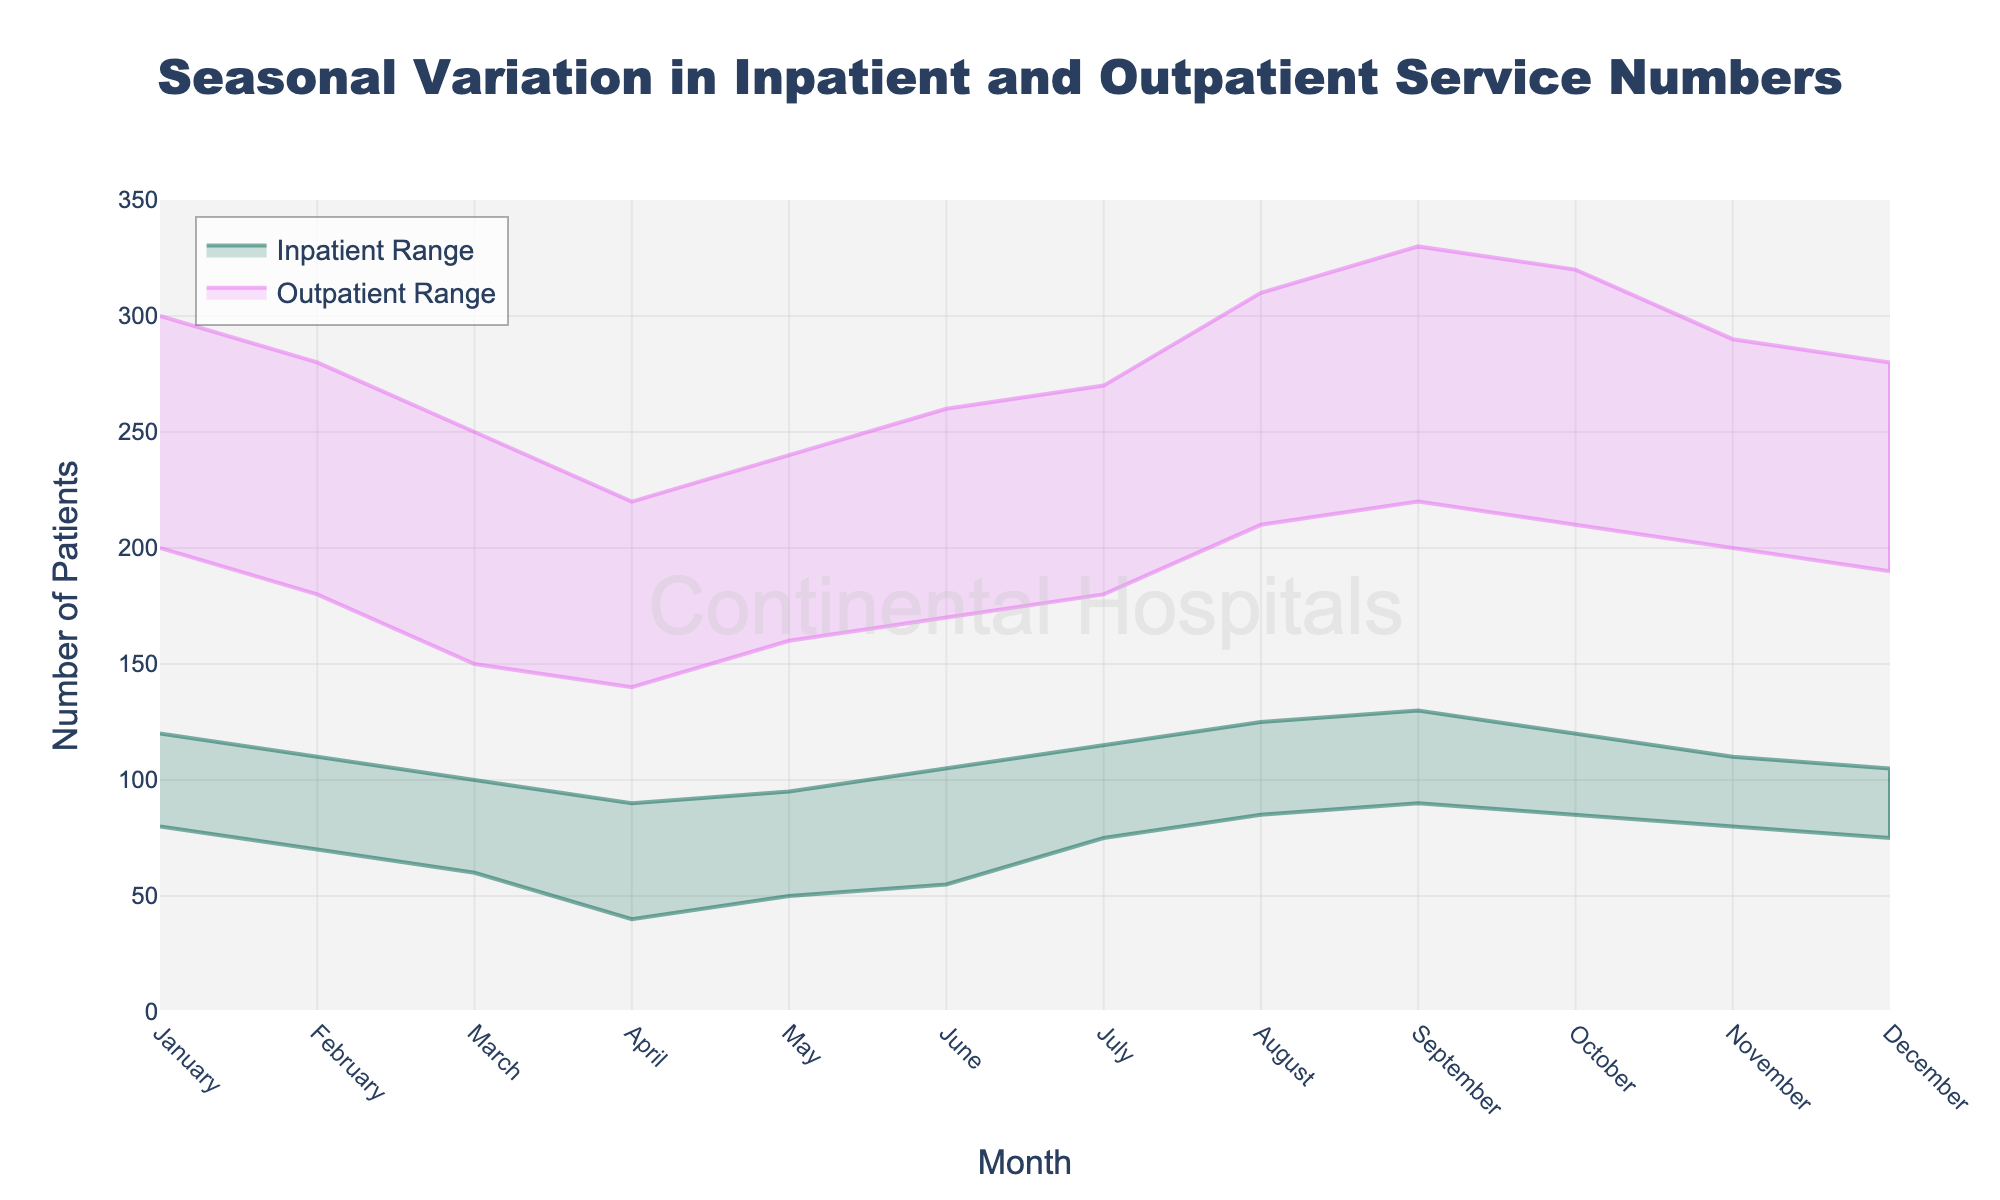what is the title of the plot? The title is located at the top center of the figure. It reads, "Seasonal Variation in Inpatient and Outpatient Service Numbers," indicating the chart’s focus.
Answer: Seasonal Variation in Inpatient and Outpatient Service Numbers What are the x-axis and y-axis titles? The x-axis title is at the bottom of the figure and reads "Month," while the y-axis title is on the left side and reads "Number of Patients."
Answer: x-axis: Month; y-axis: Number of Patients In which month is the maximum number of Inpatients the highest? The Inpatient range is represented by a green shaded area. The highest peak of the green area is in September, reaching 130 patients.
Answer: September Which month has the smallest range for Outpatient numbers? The Outpatient range is shown by the purple shaded area. April has the smallest range (140 to 220), making it just 80 patients.
Answer: April How does the range of Inpatient numbers compare between January and February? Inpatient numbers range from 80 to 120 in January and from 70 to 110 in February. The range for January (40) is larger than that for February (40 vs. 40).
range being the same.
Answer: Both 40 By how much do the minimum Inpatient numbers increase from March to April? The minimum Inpatient numbers increase from 60 in March to 40 in April. The difference is calculated as 60 - 40 = 10 patients.
Answer: 10 patients What is the difference between the maximum Outpatient numbers in June and July? The maximum Outpatient numbers are shown on the top edge of the purple area. June has a maximum of 260, and July has a maximum of 270. The difference is calculated as 270 - 260 = 10 patients.
Answer: 10 patients In which months do both the minimum and maximum Outpatient numbers reach their peak? The purple shaded area’s top and bottom edges (max and min) are highest in September, with the maximum being 330 and the minimum being 220.
Answer: September Which month shows a significant decline in both Inpatient and Outpatient numbers compared to its preceding month? By comparing the range edges, both Inpatient and Outpatient numbers show a significant decline from February to March.
Answer: March In which months are the range areas for Inpatients and Outpatients overlapping significantly? January and August show significant overlap, indicated by the green and purple shaded areas overlapping prominently in these months.
Answer: January, August 